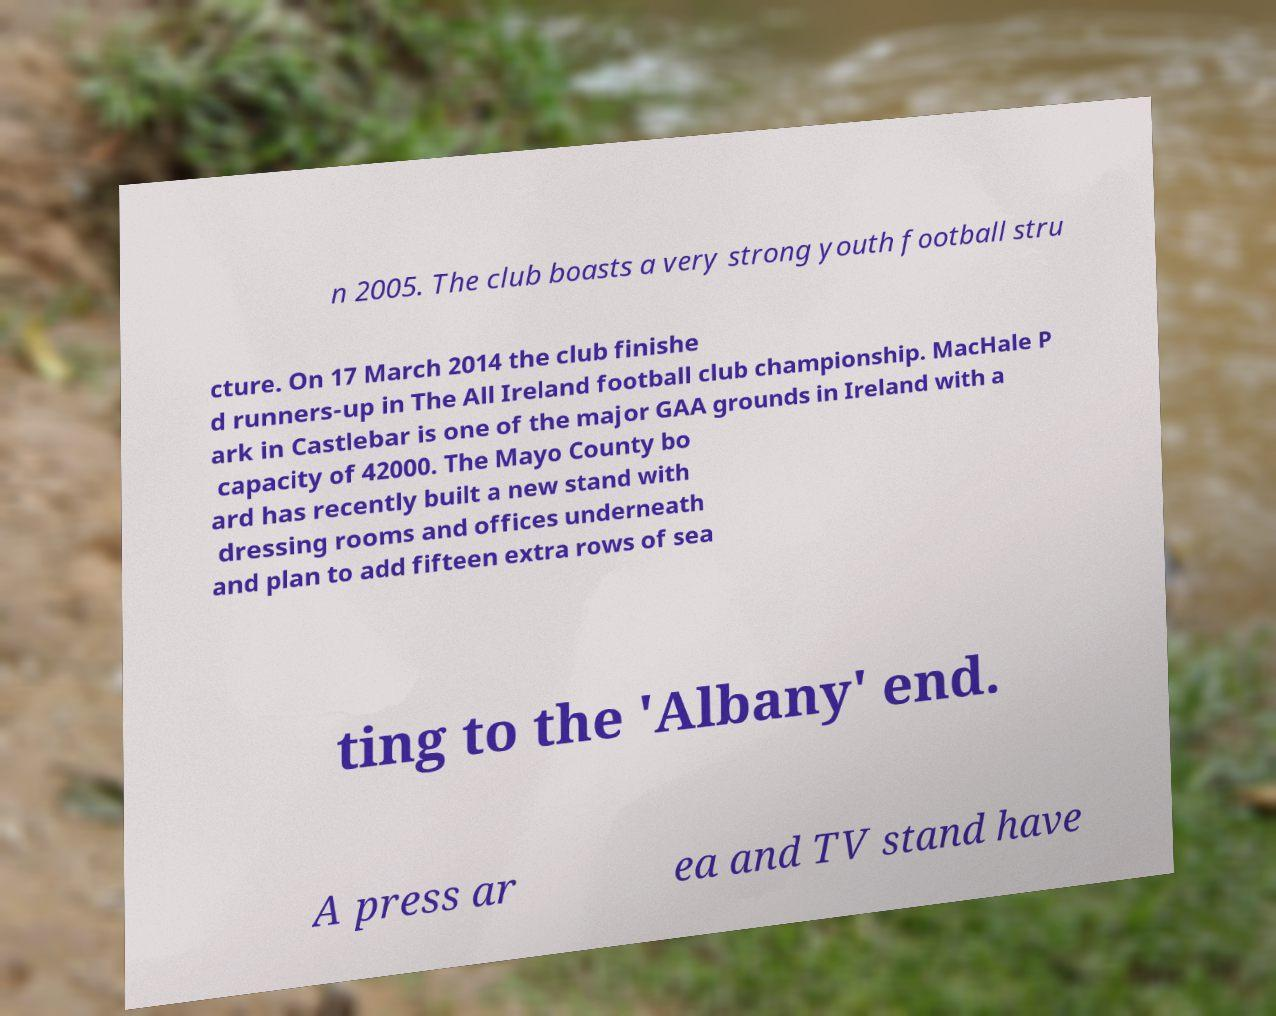Please read and relay the text visible in this image. What does it say? n 2005. The club boasts a very strong youth football stru cture. On 17 March 2014 the club finishe d runners-up in The All Ireland football club championship. MacHale P ark in Castlebar is one of the major GAA grounds in Ireland with a capacity of 42000. The Mayo County bo ard has recently built a new stand with dressing rooms and offices underneath and plan to add fifteen extra rows of sea ting to the 'Albany' end. A press ar ea and TV stand have 